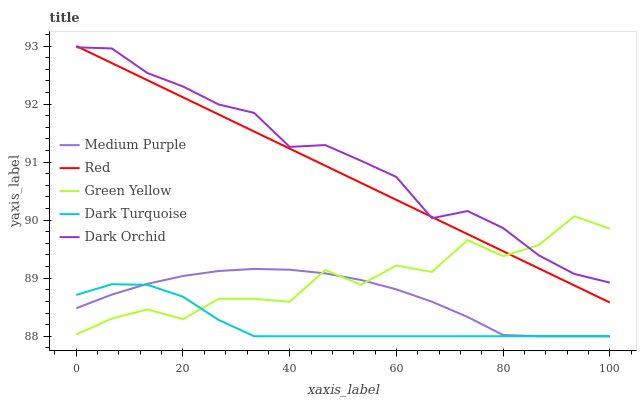Does Green Yellow have the minimum area under the curve?
Answer yes or no. No. Does Green Yellow have the maximum area under the curve?
Answer yes or no. No. Is Dark Turquoise the smoothest?
Answer yes or no. No. Is Dark Turquoise the roughest?
Answer yes or no. No. Does Green Yellow have the lowest value?
Answer yes or no. No. Does Green Yellow have the highest value?
Answer yes or no. No. Is Medium Purple less than Dark Orchid?
Answer yes or no. Yes. Is Red greater than Dark Turquoise?
Answer yes or no. Yes. Does Medium Purple intersect Dark Orchid?
Answer yes or no. No. 